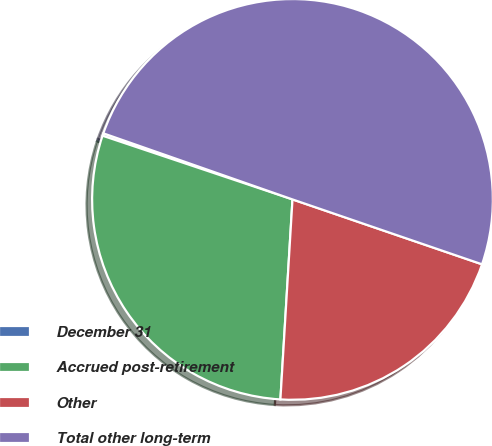Convert chart. <chart><loc_0><loc_0><loc_500><loc_500><pie_chart><fcel>December 31<fcel>Accrued post-retirement<fcel>Other<fcel>Total other long-term<nl><fcel>0.2%<fcel>29.19%<fcel>20.71%<fcel>49.9%<nl></chart> 